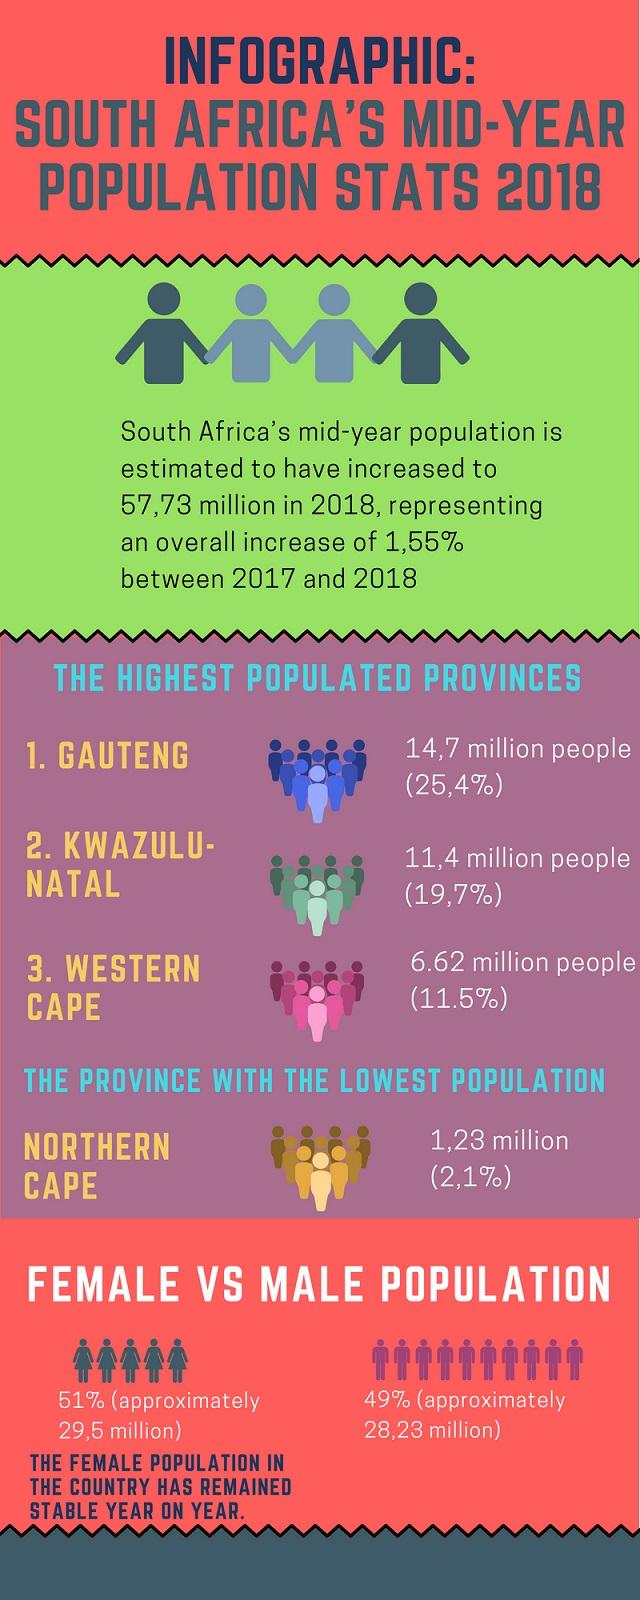Draw attention to some important aspects in this diagram. In terms of the proportion of the total population, the Gauteng and Western Cape provinces together account for 36.9%. The infographic contains 4 provinces. 